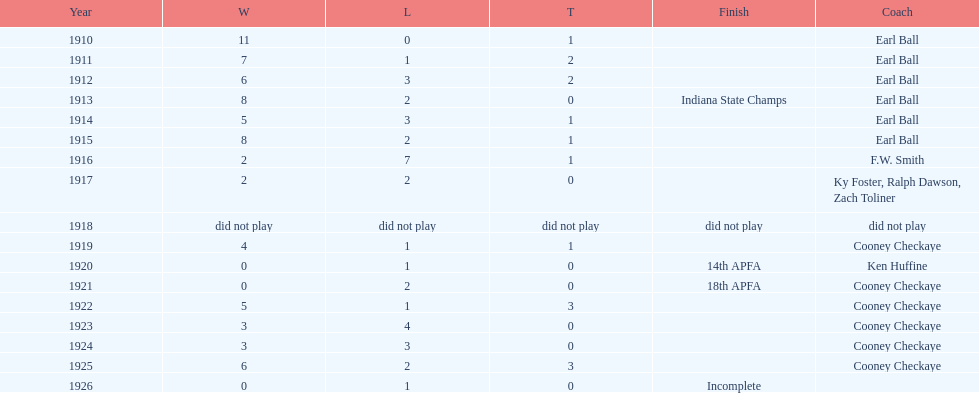During the period from 1910 to 1925, the muncie flyers were active in all years except one. which year was that? 1918. 